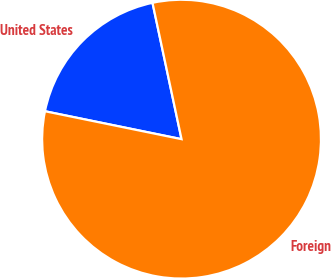<chart> <loc_0><loc_0><loc_500><loc_500><pie_chart><fcel>United States<fcel>Foreign<nl><fcel>18.45%<fcel>81.55%<nl></chart> 